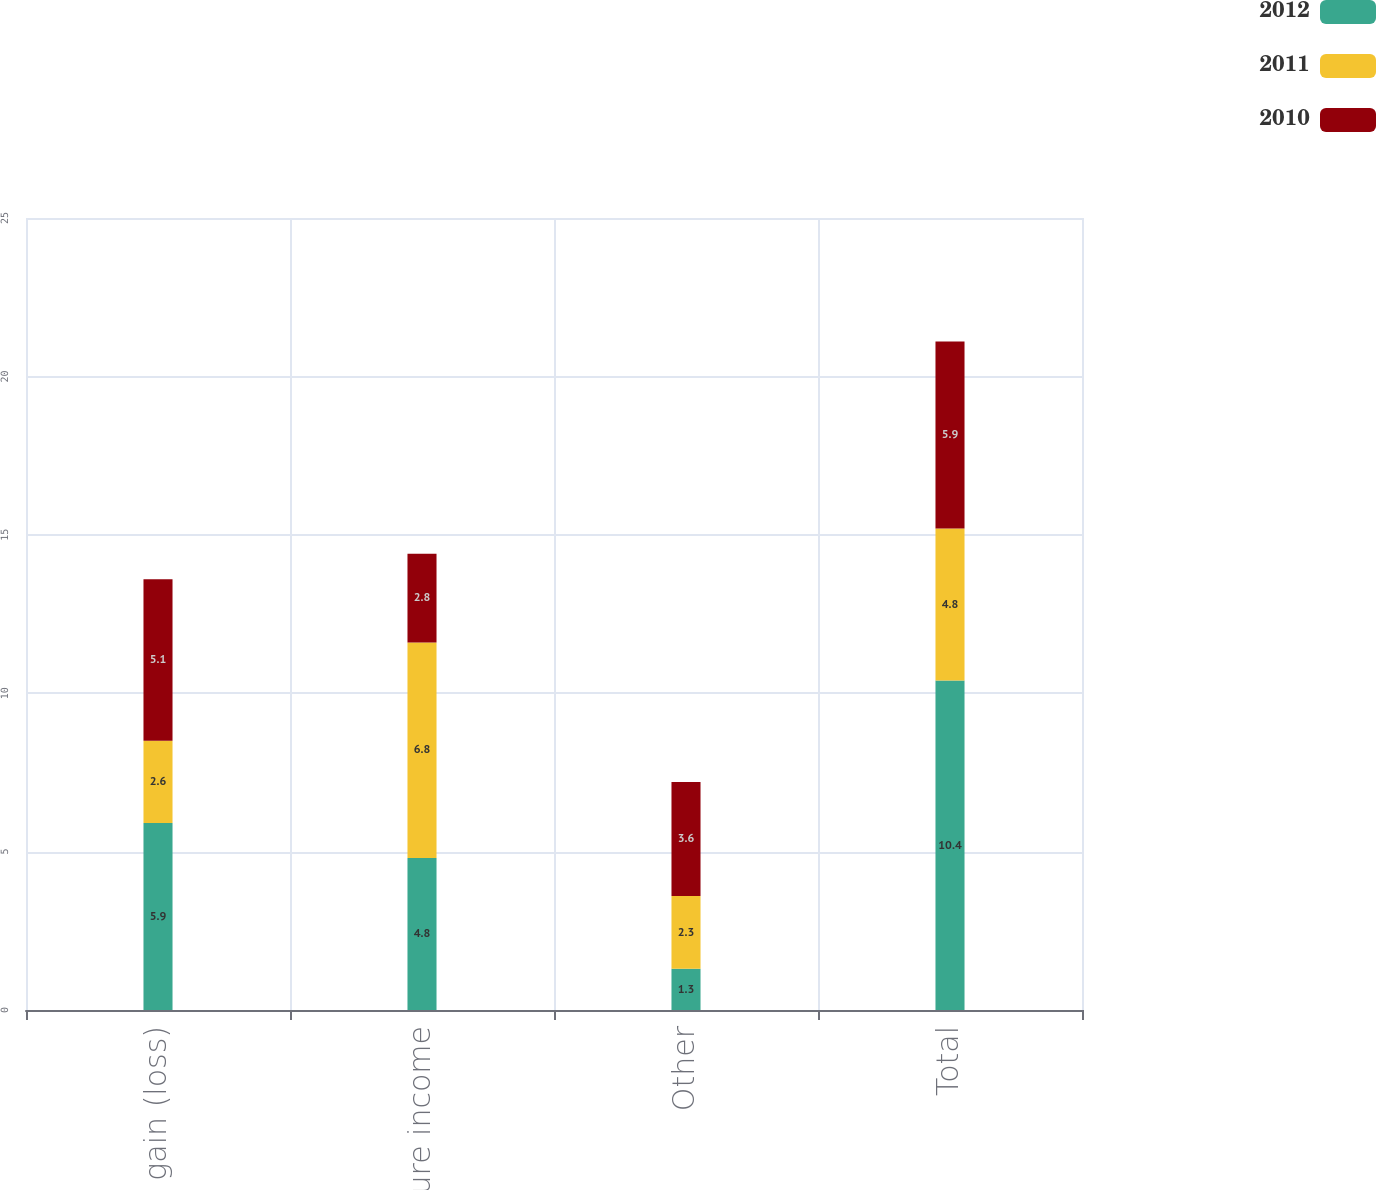Convert chart. <chart><loc_0><loc_0><loc_500><loc_500><stacked_bar_chart><ecel><fcel>FX gain (loss)<fcel>Joint venture income<fcel>Other<fcel>Total<nl><fcel>2012<fcel>5.9<fcel>4.8<fcel>1.3<fcel>10.4<nl><fcel>2011<fcel>2.6<fcel>6.8<fcel>2.3<fcel>4.8<nl><fcel>2010<fcel>5.1<fcel>2.8<fcel>3.6<fcel>5.9<nl></chart> 